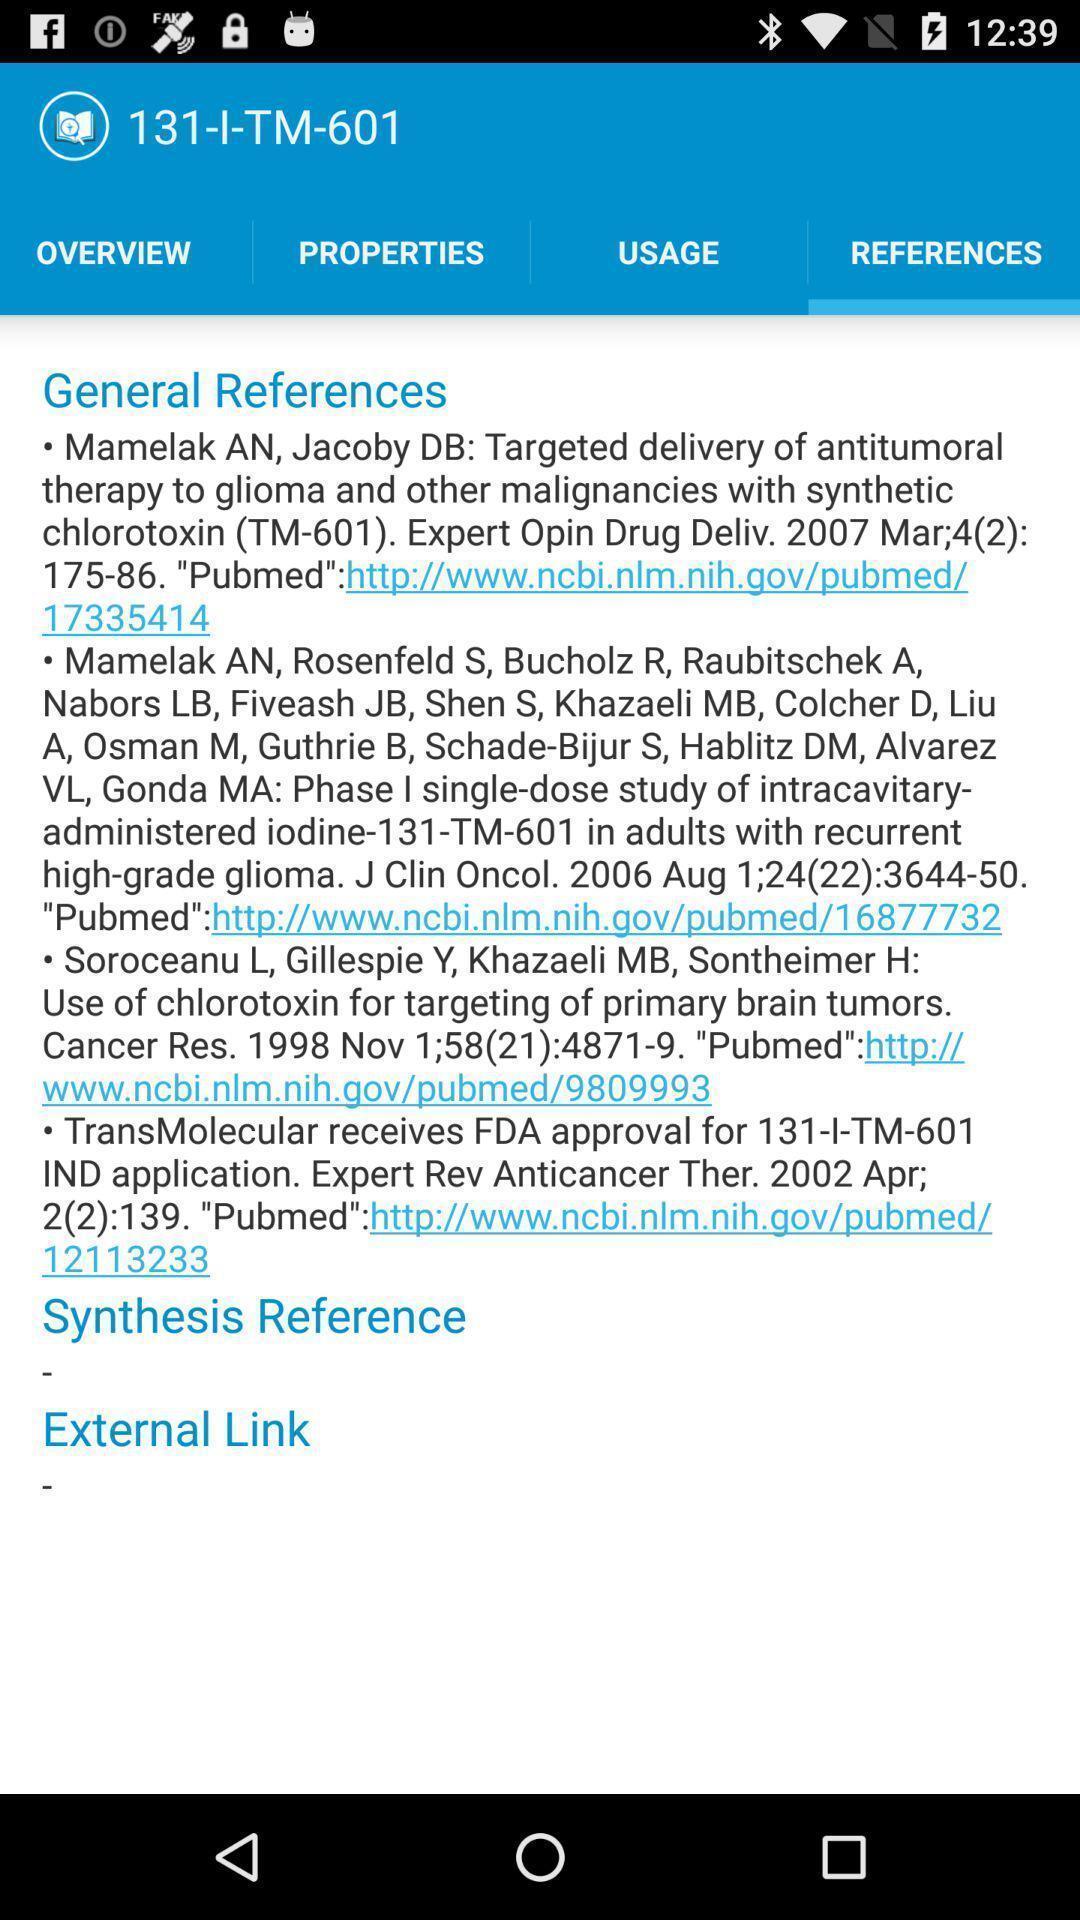Tell me about the visual elements in this screen capture. Screen displaying the references page. 